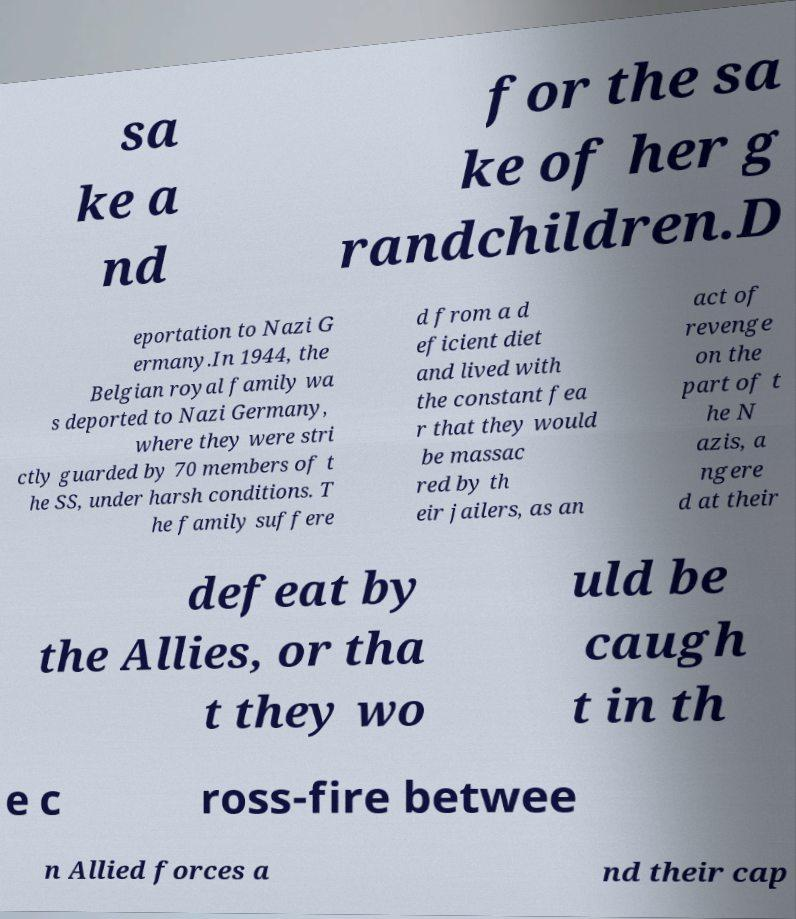Please read and relay the text visible in this image. What does it say? sa ke a nd for the sa ke of her g randchildren.D eportation to Nazi G ermany.In 1944, the Belgian royal family wa s deported to Nazi Germany, where they were stri ctly guarded by 70 members of t he SS, under harsh conditions. T he family suffere d from a d eficient diet and lived with the constant fea r that they would be massac red by th eir jailers, as an act of revenge on the part of t he N azis, a ngere d at their defeat by the Allies, or tha t they wo uld be caugh t in th e c ross-fire betwee n Allied forces a nd their cap 